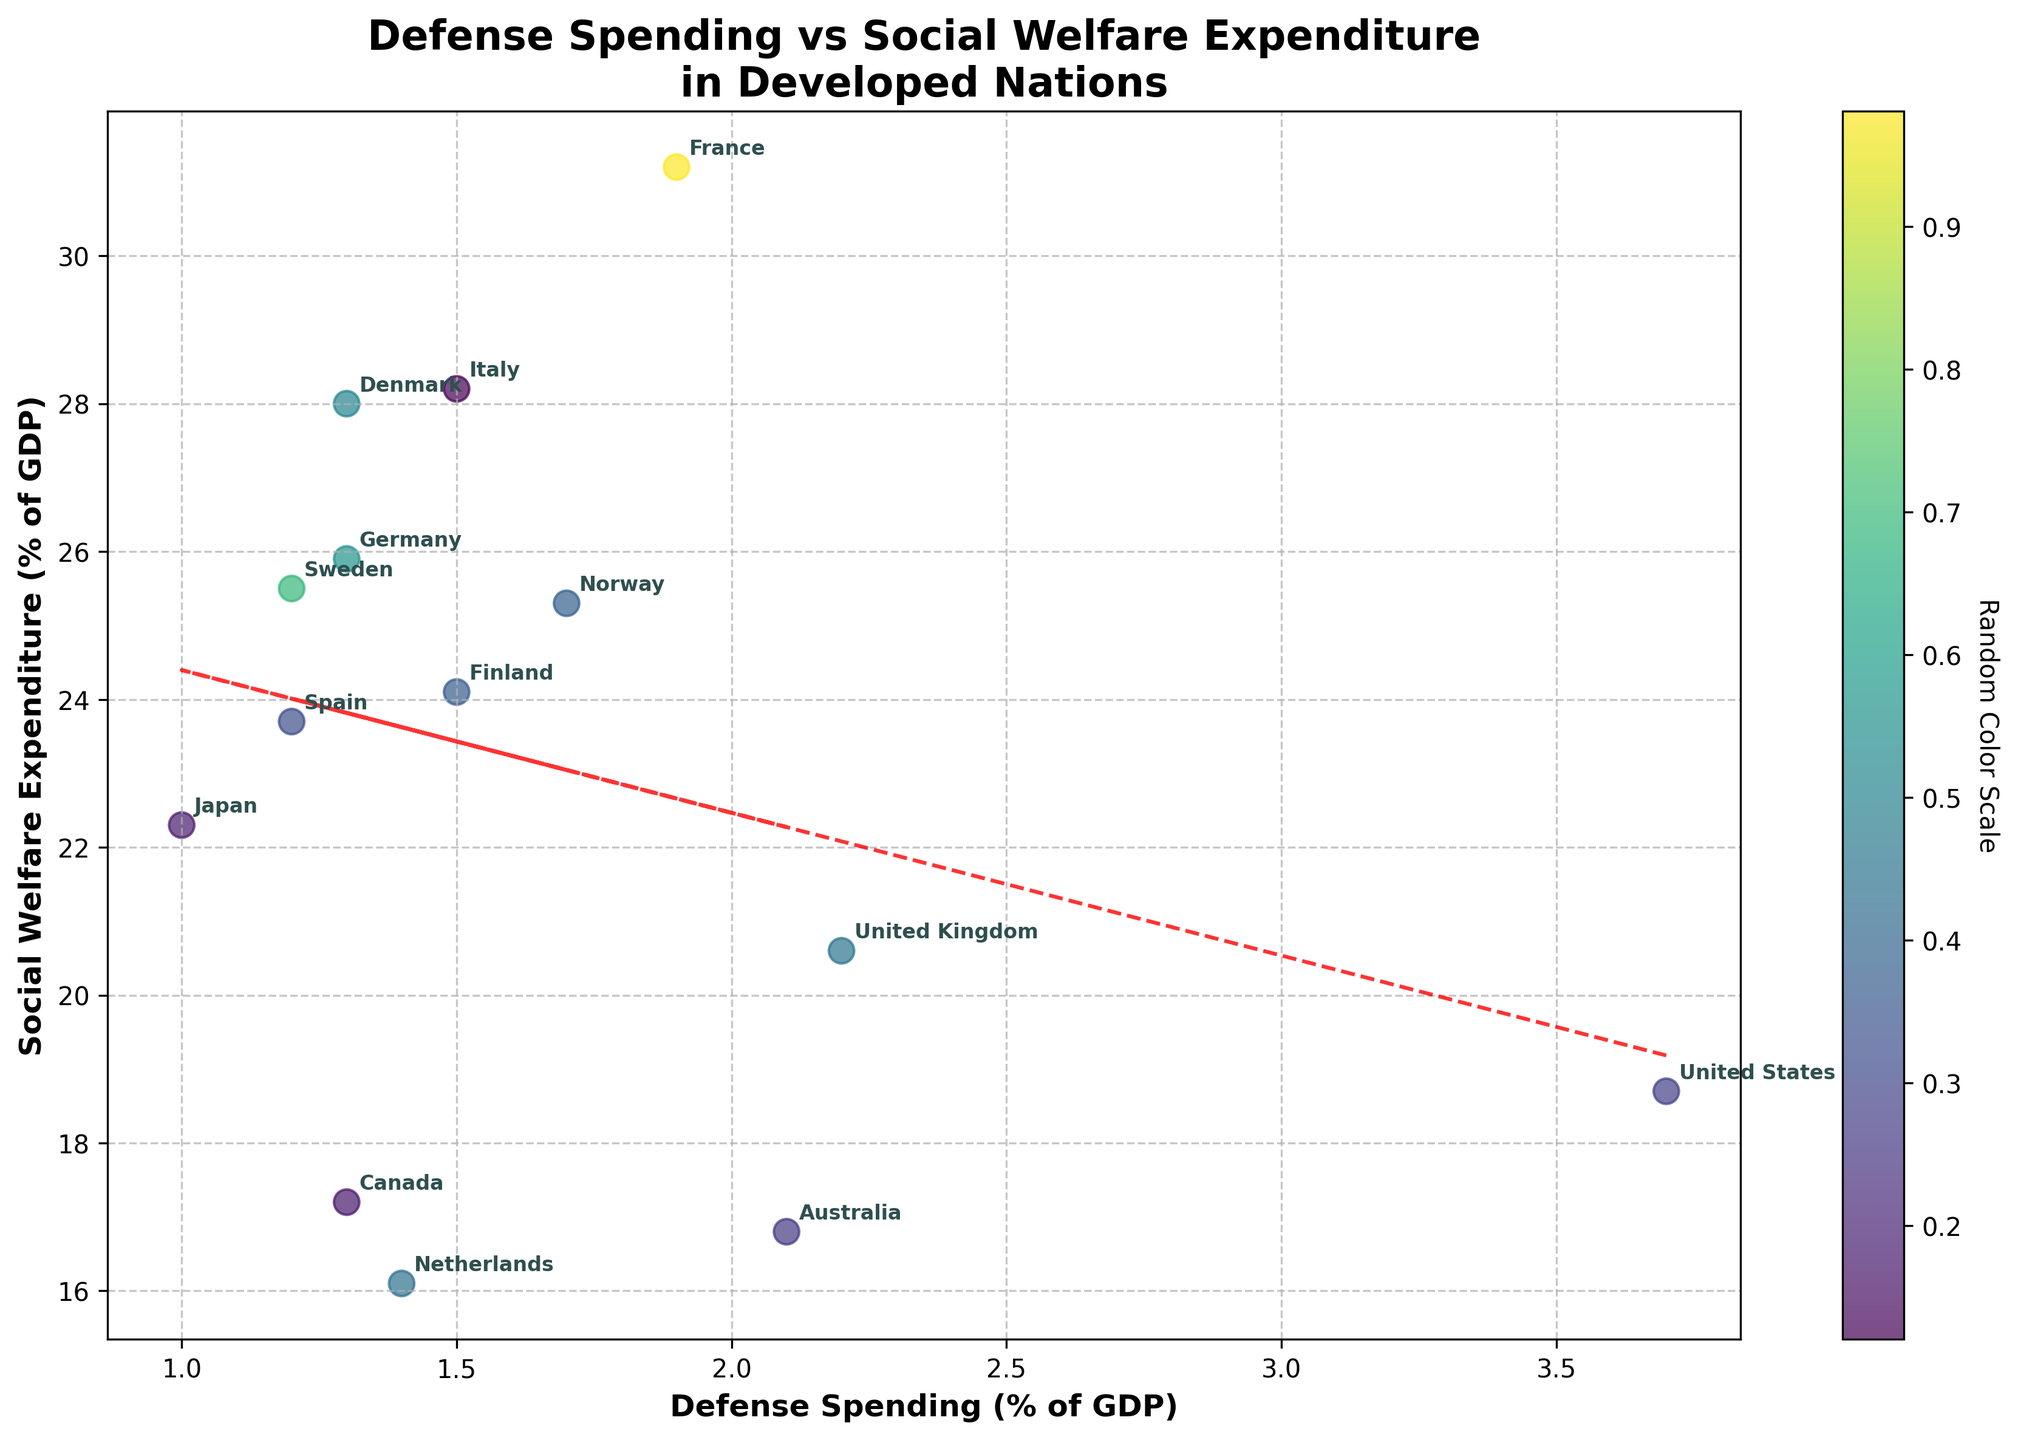What is the title of the figure? The title is usually at the top of the figure. It provides a concise summary of what the data represents in the plot.
Answer: Defense Spending vs Social Welfare Expenditure in Developed Nations Which country has the highest defense spending? To find this, you need to look at the x-axis (Defense Spending) and find the point farthest to the right. Then check the label of that point.
Answer: United States What is the approximate value of social welfare expenditure for France? Locate France on the plot and then read the corresponding y-axis value, which represents social welfare expenditure.
Answer: About 31.2% of GDP How many countries have defense spending below 1.5% of GDP? Review the lower portion of the x-axis (less than 1.5%) and count the number of points within this range.
Answer: Six Which country has both defense spending and social welfare expenditure closest to the average values of all countries? Calculate the average defense spending and social welfare expenditure by summing the values and dividing by the number of countries. Then, find the point closest to these average values. The average defense spending is approximately 1.64% and social welfare expenditure is approximately 23.7%.
Answer: Spain What is the relationship between defense spending and social welfare expenditure as suggested by the trendline? A trendline usually indicates the general direction or relationship; in this case, review the slope of the red dashed line.
Answer: Negative correlation Which countries have higher social welfare expenditure but lower defense spending than Germany? Identify Germany's position, then locate points above and to the left of Germany's data point.
Answer: France, Italy, Spain, Sweden, Norway, Denmark, Finland Which countries have both defense spending greater than 2% and social welfare expenditure less than 20%? Find the data points that satisfy both conditions by looking to the right of the 2% mark on the x-axis and below the 20% mark on the y-axis.
Answer: United Kingdom, Australia How does Canada's social welfare expenditure compare to Japan's? Look at the positions of Canada and Japan on the y-axis and compare their values.
Answer: Canada's social welfare expenditure is lower than Japan's 